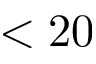<formula> <loc_0><loc_0><loc_500><loc_500>< 2 0</formula> 